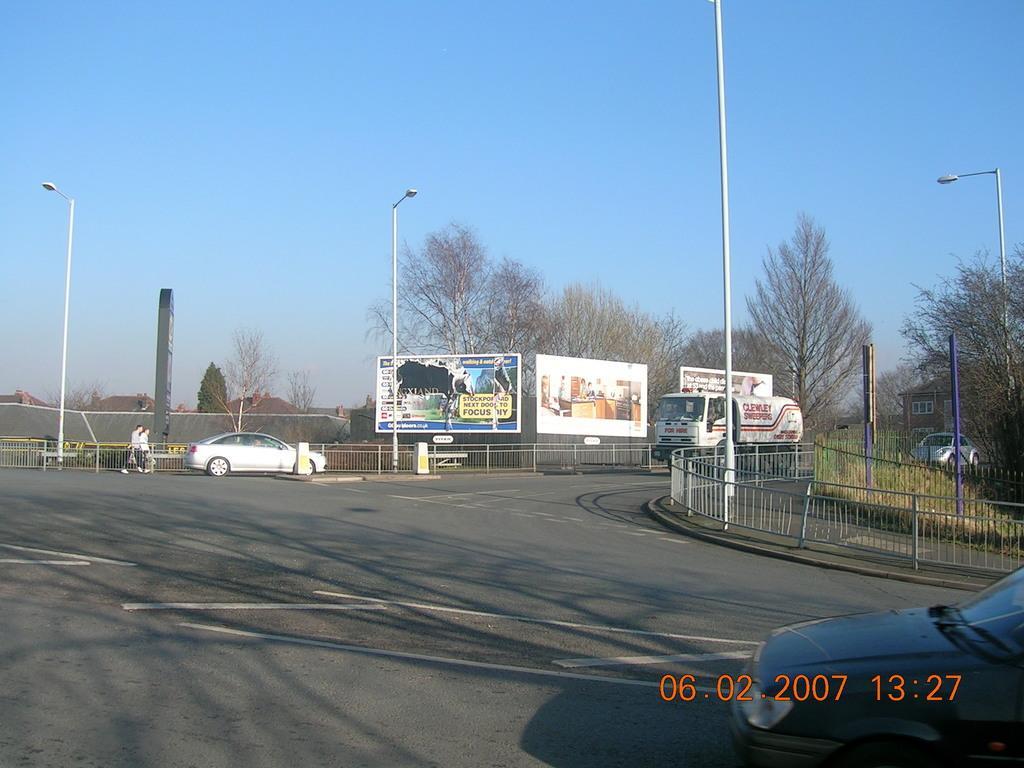In one or two sentences, can you explain what this image depicts? In this image at the center there are vehicles on the road. On both right and left side of the image there are metal grills, street lights. At the background there are buildings, trees and at the top there is sky. 